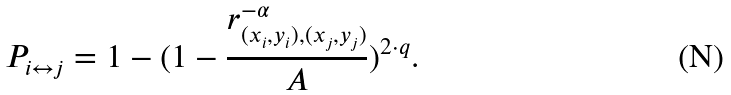<formula> <loc_0><loc_0><loc_500><loc_500>P _ { i \leftrightarrow { j } } = 1 - ( 1 - \frac { r _ { ( x _ { i } , y _ { i } ) , ( x _ { j } , y _ { j } ) } ^ { - \alpha } } { A } ) ^ { 2 \cdot { q } } .</formula> 